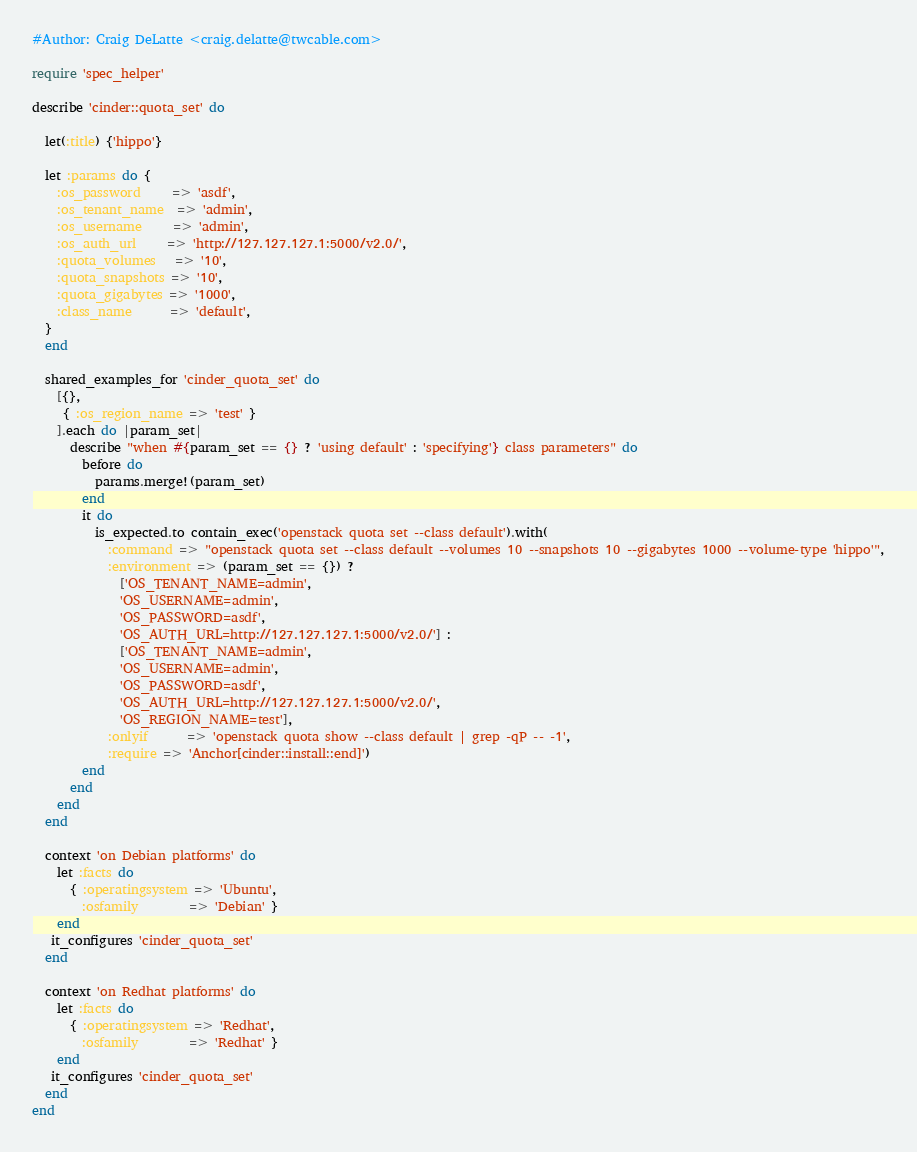<code> <loc_0><loc_0><loc_500><loc_500><_Ruby_>#Author: Craig DeLatte <craig.delatte@twcable.com>

require 'spec_helper'

describe 'cinder::quota_set' do

  let(:title) {'hippo'}

  let :params do {
    :os_password     => 'asdf',
    :os_tenant_name  => 'admin',
    :os_username     => 'admin',
    :os_auth_url     => 'http://127.127.127.1:5000/v2.0/',
    :quota_volumes   => '10',
    :quota_snapshots => '10',
    :quota_gigabytes => '1000',
    :class_name      => 'default',
  }
  end

  shared_examples_for 'cinder_quota_set' do
    [{},
     { :os_region_name => 'test' }
    ].each do |param_set|
      describe "when #{param_set == {} ? 'using default' : 'specifying'} class parameters" do
        before do
          params.merge!(param_set)
        end
        it do
          is_expected.to contain_exec('openstack quota set --class default').with(
            :command => "openstack quota set --class default --volumes 10 --snapshots 10 --gigabytes 1000 --volume-type 'hippo'",
            :environment => (param_set == {}) ?
              ['OS_TENANT_NAME=admin',
              'OS_USERNAME=admin',
              'OS_PASSWORD=asdf',
              'OS_AUTH_URL=http://127.127.127.1:5000/v2.0/'] :
              ['OS_TENANT_NAME=admin',
              'OS_USERNAME=admin',
              'OS_PASSWORD=asdf',
              'OS_AUTH_URL=http://127.127.127.1:5000/v2.0/',
              'OS_REGION_NAME=test'],
            :onlyif      => 'openstack quota show --class default | grep -qP -- -1',
            :require => 'Anchor[cinder::install::end]')
        end
      end
    end
  end

  context 'on Debian platforms' do
    let :facts do
      { :operatingsystem => 'Ubuntu',
        :osfamily        => 'Debian' }
    end
   it_configures 'cinder_quota_set'
  end

  context 'on Redhat platforms' do
    let :facts do
      { :operatingsystem => 'Redhat',
        :osfamily        => 'Redhat' }
    end
   it_configures 'cinder_quota_set'
  end
end
</code> 